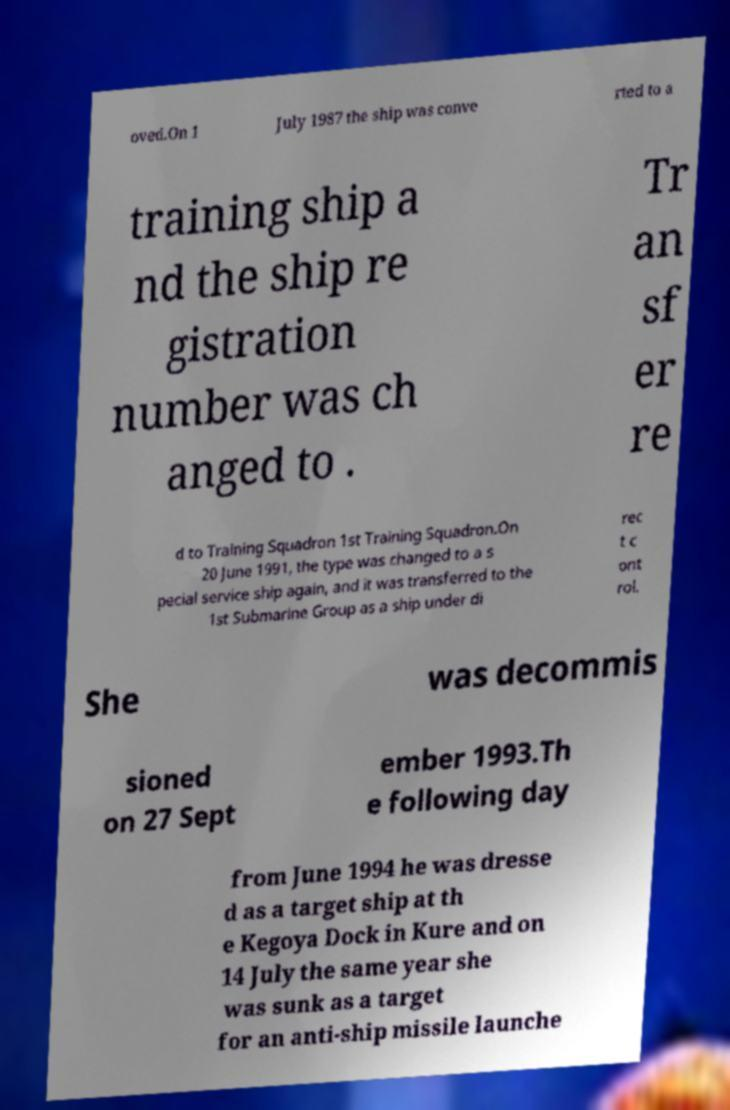Could you assist in decoding the text presented in this image and type it out clearly? oved.On 1 July 1987 the ship was conve rted to a training ship a nd the ship re gistration number was ch anged to . Tr an sf er re d to Training Squadron 1st Training Squadron.On 20 June 1991, the type was changed to a s pecial service ship again, and it was transferred to the 1st Submarine Group as a ship under di rec t c ont rol. She was decommis sioned on 27 Sept ember 1993.Th e following day from June 1994 he was dresse d as a target ship at th e Kegoya Dock in Kure and on 14 July the same year she was sunk as a target for an anti-ship missile launche 